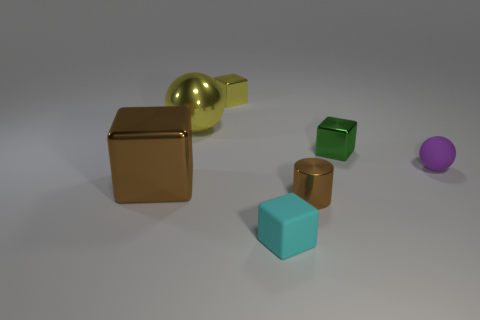There is a metal thing that is both in front of the small purple rubber sphere and on the right side of the big brown shiny block; what is its shape?
Your response must be concise. Cylinder. How many small yellow metallic things are left of the matte object that is in front of the small purple rubber sphere?
Provide a short and direct response. 1. How many things are either small things that are behind the big metallic cube or big brown metal things?
Your answer should be very brief. 4. How big is the brown thing that is on the right side of the yellow block?
Ensure brevity in your answer.  Small. What is the brown cylinder made of?
Your answer should be compact. Metal. What is the shape of the large metal object in front of the matte object that is behind the shiny cylinder?
Provide a succinct answer. Cube. How many other objects are the same shape as the tiny purple matte object?
Keep it short and to the point. 1. Are there any tiny things on the left side of the purple thing?
Your answer should be compact. Yes. The big cube is what color?
Give a very brief answer. Brown. Does the cylinder have the same color as the large shiny cube left of the cyan matte cube?
Offer a very short reply. Yes. 